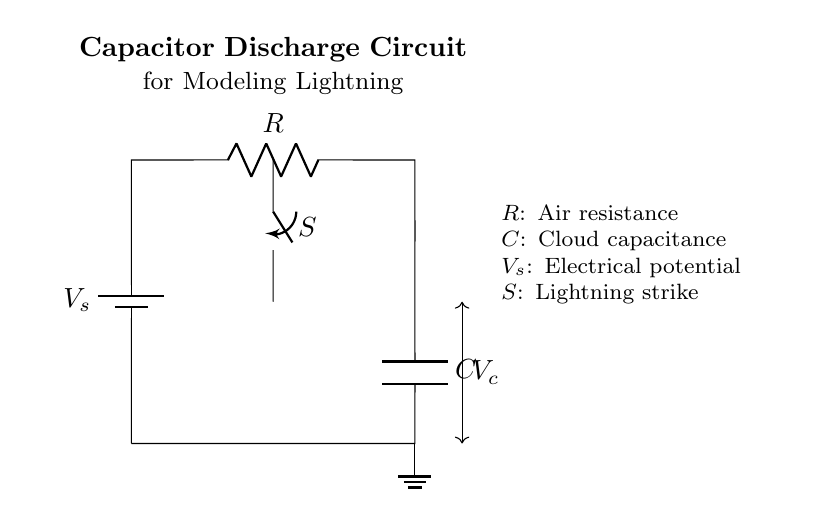What component is used to store electrical energy? The circuit diagram shows a capacitor labeled as 'C'. Capacitors are designed to store electrical energy in an electric field.
Answer: Capacitor What does the symbol 'S' represent in this circuit? The symbol 'S' represents a switch, which is used to control the flow of current in the circuit, simulating the conditions that might occur during a lightning strike.
Answer: Switch What is the role of the resistor in this circuit? The resistor, labeled 'R', represents air resistance, which affects the rate at which the capacitor discharges its stored energy over time, influencing the modeling of lightning.
Answer: Air resistance What is the function of the battery in this circuit? The battery, labeled as 'V_s', provides the electrical potential needed to charge the capacitor before it discharges. It acts as the source of voltage in the circuit.
Answer: Electrical potential What is the voltage across the capacitor labeled as? The voltage across the capacitor is labeled as 'V_c' in the circuit diagram, indicating the potential difference that builds up across the capacitor during charging and discharging.
Answer: V_c If the switch 'S' is closed, what happens to the capacitor? When the switch is closed, the capacitor discharges its stored energy through the resistor, allowing current to flow until the capacitor is depleted of charge.
Answer: Discharge How does the resistance 'R' affect the capacitor discharge time? The resistance 'R' determines the rate at which the capacitor discharges; a higher resistance will result in a slower discharge time, while a lower resistance will allow for a faster discharge.
Answer: Affects discharge time 